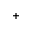Convert formula to latex. <formula><loc_0><loc_0><loc_500><loc_500>^ { + }</formula> 